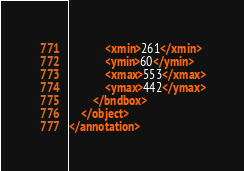<code> <loc_0><loc_0><loc_500><loc_500><_XML_>			<xmin>261</xmin>
			<ymin>60</ymin>
			<xmax>553</xmax>
			<ymax>442</ymax>
		</bndbox>
	</object>
</annotation>
</code> 